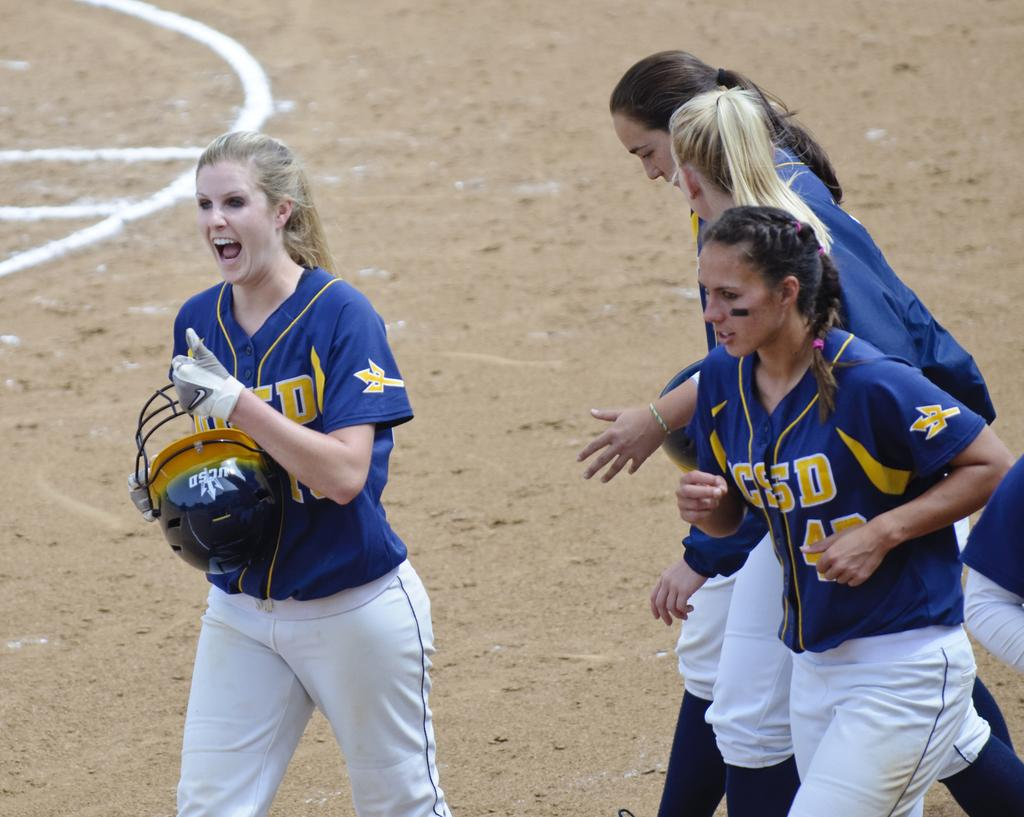How many people are in the image? There are five persons in the image. What is the lady holding in her hand? The lady is holding a helmet in her hand. What can be seen beneath the people in the image? There is a ground visible in the image. How many frogs are jumping on the ground in the image? There are no frogs present in the image; it only features five persons and a lady holding a helmet. What time of day is it in the image? The time of day cannot be determined from the image, as there are no clues or indicators present. 